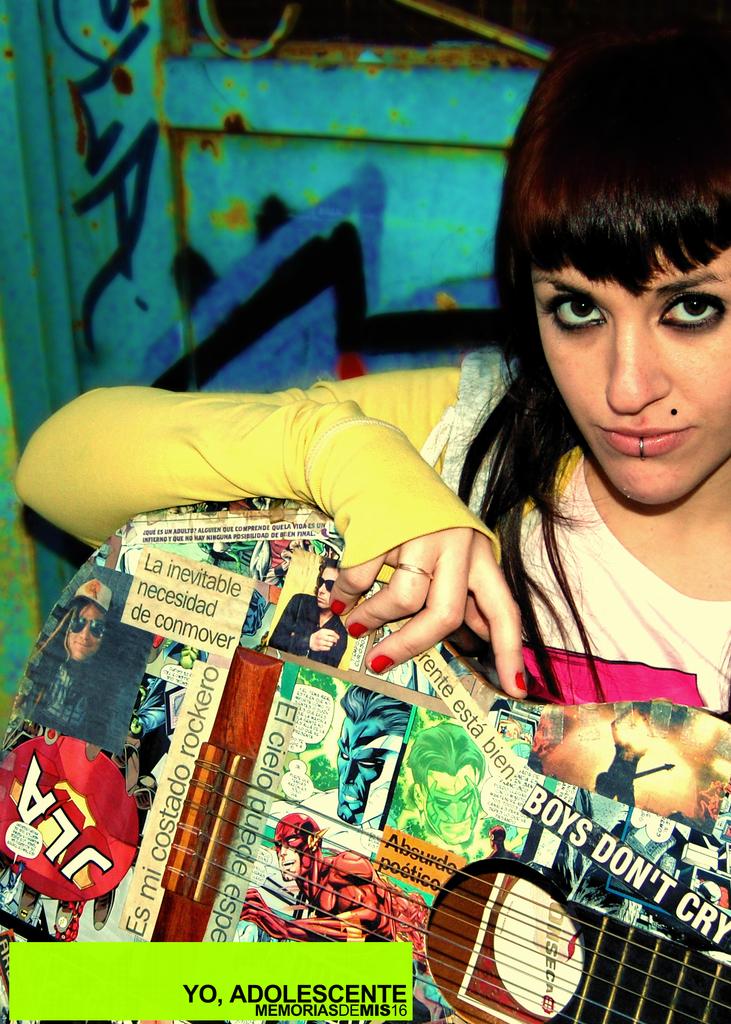Who does not cry?
Offer a very short reply. Boys. 